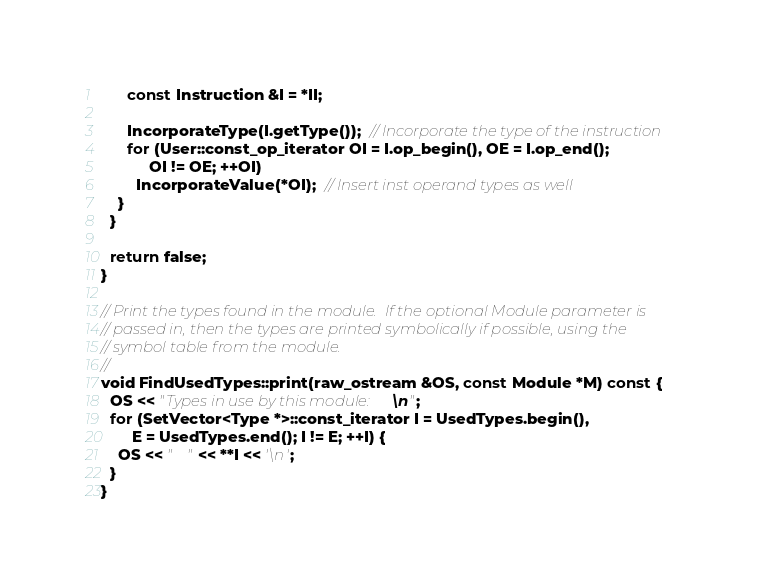<code> <loc_0><loc_0><loc_500><loc_500><_C++_>      const Instruction &I = *II;

      IncorporateType(I.getType());  // Incorporate the type of the instruction
      for (User::const_op_iterator OI = I.op_begin(), OE = I.op_end();
           OI != OE; ++OI)
        IncorporateValue(*OI);  // Insert inst operand types as well
    }
  }

  return false;
}

// Print the types found in the module.  If the optional Module parameter is
// passed in, then the types are printed symbolically if possible, using the
// symbol table from the module.
//
void FindUsedTypes::print(raw_ostream &OS, const Module *M) const {
  OS << "Types in use by this module:\n";
  for (SetVector<Type *>::const_iterator I = UsedTypes.begin(),
       E = UsedTypes.end(); I != E; ++I) {
    OS << "   " << **I << '\n';
  }
}
</code> 